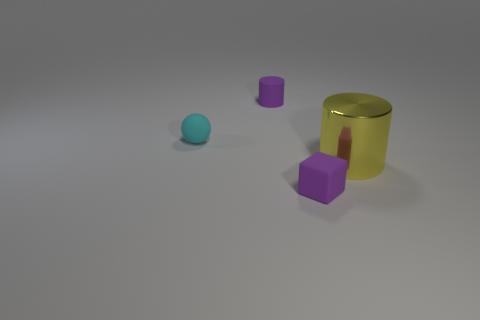Add 4 small rubber blocks. How many objects exist? 8 Subtract all spheres. How many objects are left? 3 Add 3 green cylinders. How many green cylinders exist? 3 Subtract 0 green blocks. How many objects are left? 4 Subtract all large cyan rubber balls. Subtract all large yellow shiny cylinders. How many objects are left? 3 Add 3 small purple cubes. How many small purple cubes are left? 4 